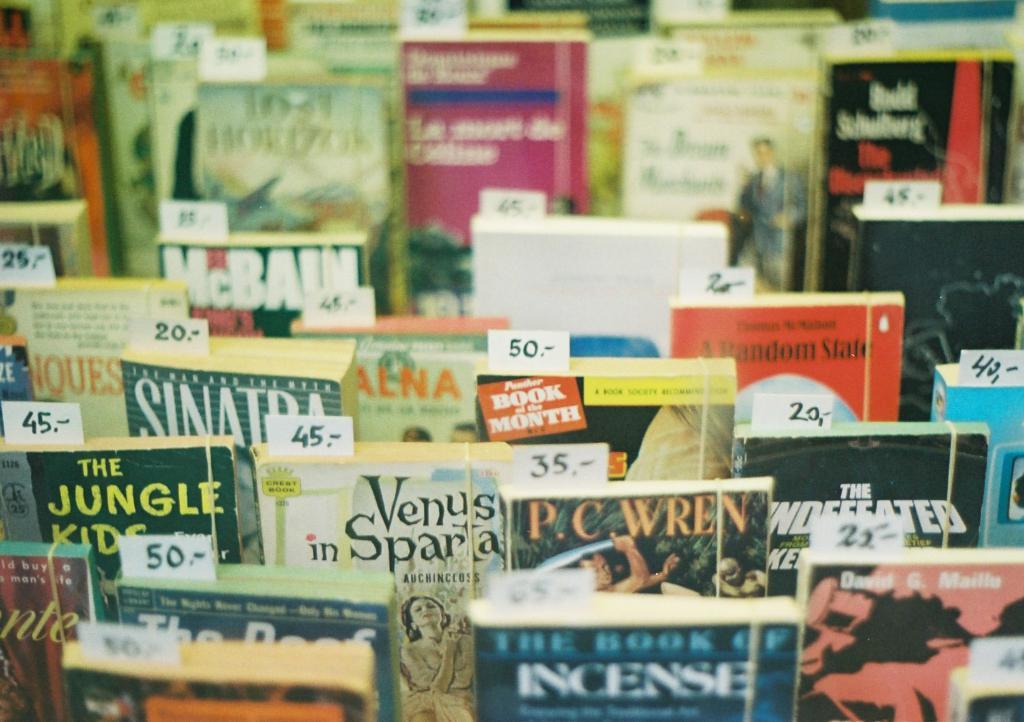Provide a one-sentence caption for the provided image. A series of books at a bookstore with prices on them. 